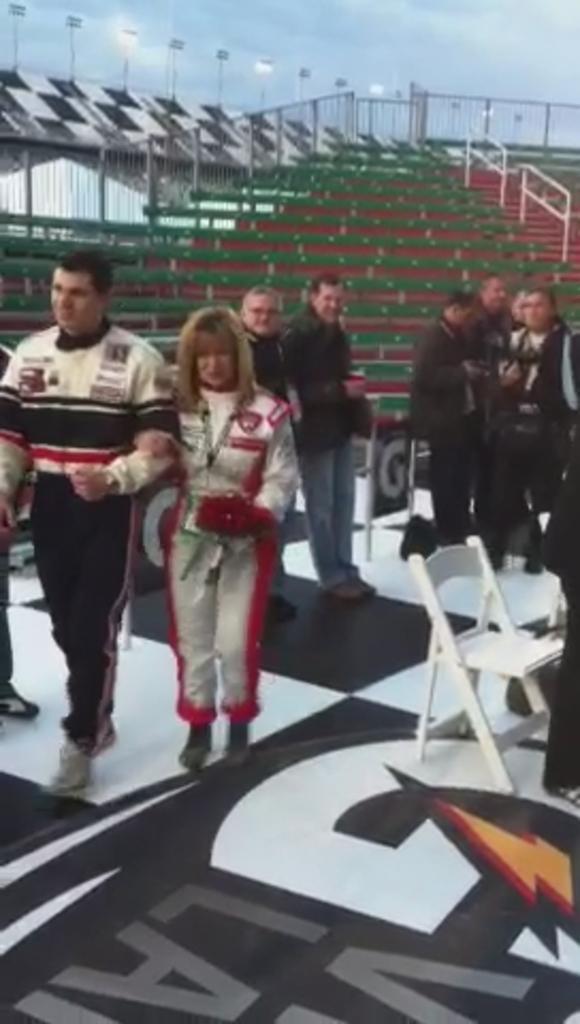Can you describe this image briefly? In this image, on the left side, we can see two people walking, there are some people standing, in the background, we can see a fence and we can see some chairs, at the top we can see the sky. 